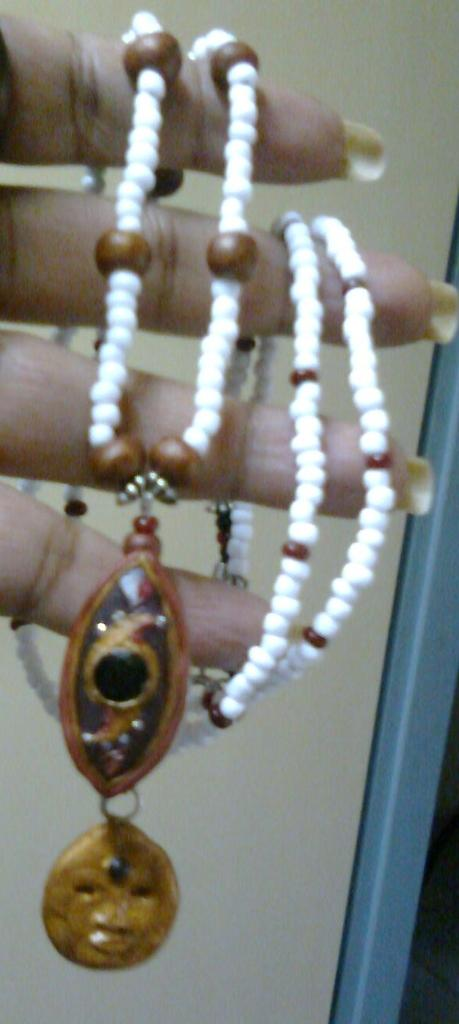What can be seen in the image related to a person's body part? There is a person's hand in the image. What is the hand holding? The hand is holding a chain. What type of voice can be heard coming from the hand in the image? There is no voice present in the image, as it only features a hand holding a chain. 